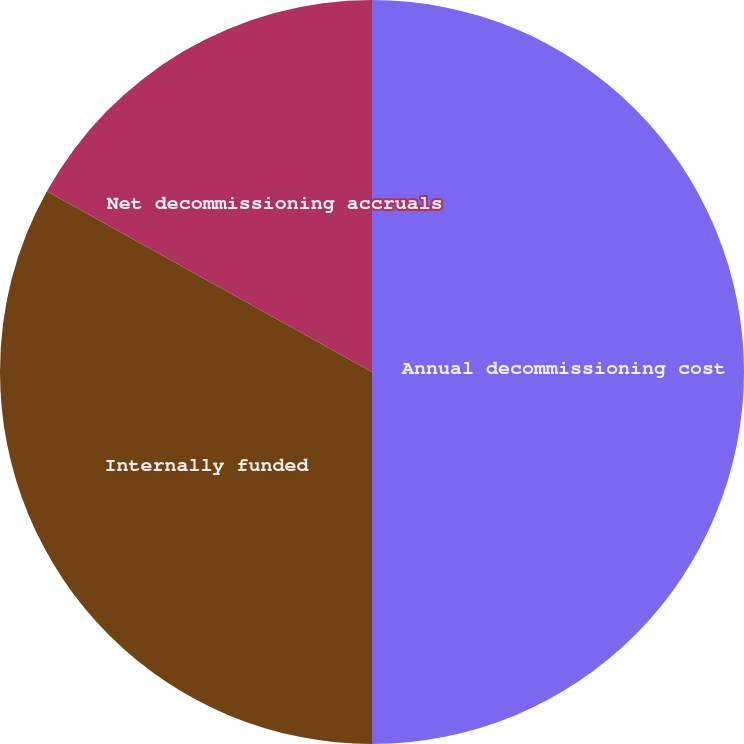Convert chart to OTSL. <chart><loc_0><loc_0><loc_500><loc_500><pie_chart><fcel>Annual decommissioning cost<fcel>Internally funded<fcel>Net decommissioning accruals<nl><fcel>50.0%<fcel>33.08%<fcel>16.92%<nl></chart> 